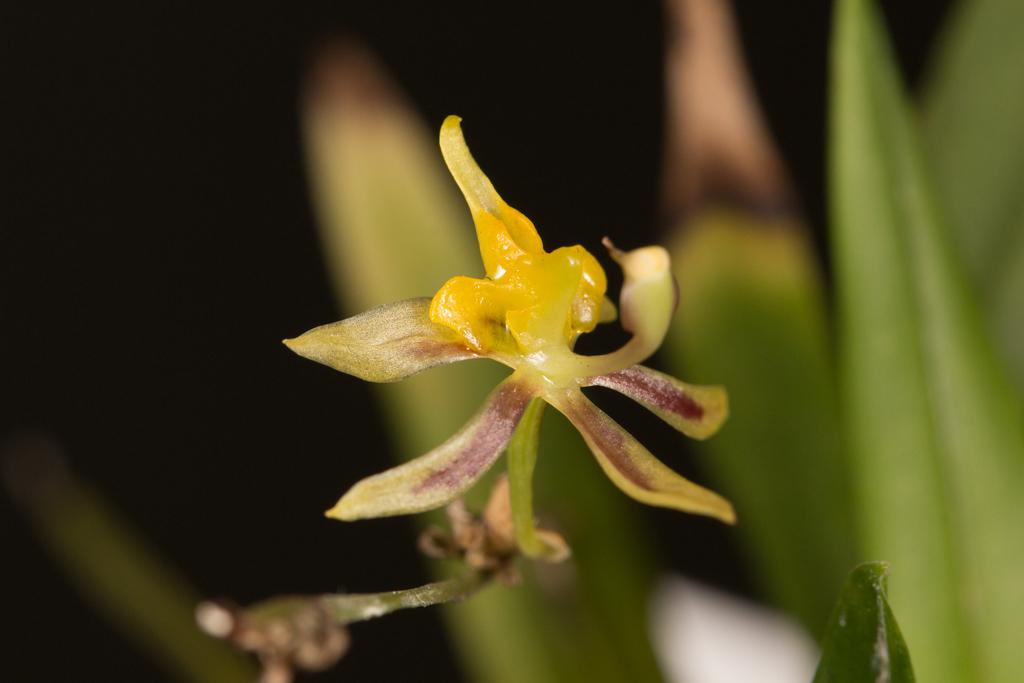What is the main subject of the image? There is a flower in the image. What can be seen behind the flower? There are leaves behind the flower in the image. What type of bridge can be seen in the image? There is no bridge present in the image; it features a flower and leaves. How many fingers are visible in the image? There are no fingers visible in the image; it features a flower and leaves. 